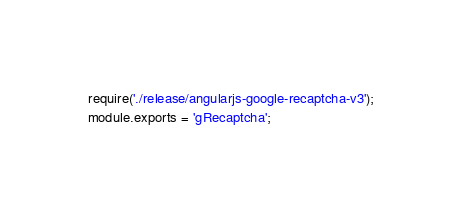<code> <loc_0><loc_0><loc_500><loc_500><_JavaScript_>require('./release/angularjs-google-recaptcha-v3');
module.exports = 'gRecaptcha';
</code> 